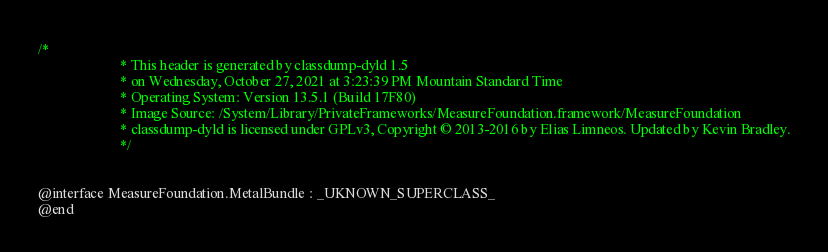<code> <loc_0><loc_0><loc_500><loc_500><_C_>/*
                       * This header is generated by classdump-dyld 1.5
                       * on Wednesday, October 27, 2021 at 3:23:39 PM Mountain Standard Time
                       * Operating System: Version 13.5.1 (Build 17F80)
                       * Image Source: /System/Library/PrivateFrameworks/MeasureFoundation.framework/MeasureFoundation
                       * classdump-dyld is licensed under GPLv3, Copyright © 2013-2016 by Elias Limneos. Updated by Kevin Bradley.
                       */


@interface MeasureFoundation.MetalBundle : _UKNOWN_SUPERCLASS_
@end

</code> 